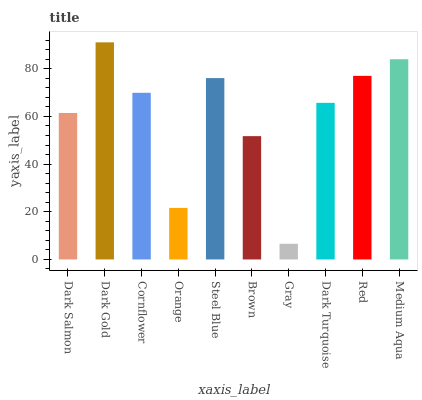Is Gray the minimum?
Answer yes or no. Yes. Is Dark Gold the maximum?
Answer yes or no. Yes. Is Cornflower the minimum?
Answer yes or no. No. Is Cornflower the maximum?
Answer yes or no. No. Is Dark Gold greater than Cornflower?
Answer yes or no. Yes. Is Cornflower less than Dark Gold?
Answer yes or no. Yes. Is Cornflower greater than Dark Gold?
Answer yes or no. No. Is Dark Gold less than Cornflower?
Answer yes or no. No. Is Cornflower the high median?
Answer yes or no. Yes. Is Dark Turquoise the low median?
Answer yes or no. Yes. Is Dark Turquoise the high median?
Answer yes or no. No. Is Steel Blue the low median?
Answer yes or no. No. 